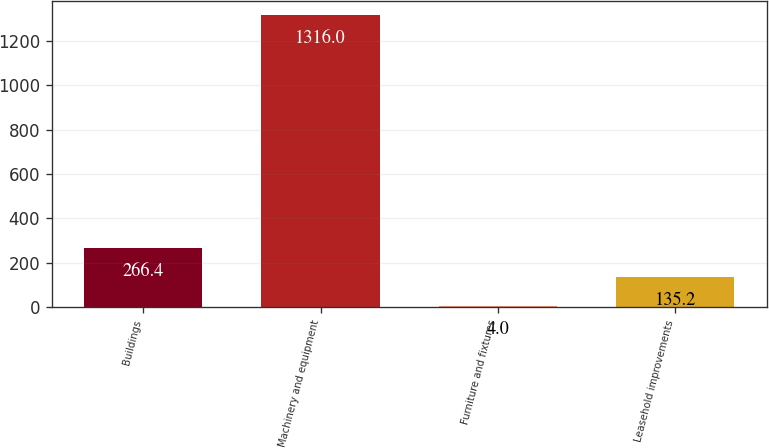Convert chart. <chart><loc_0><loc_0><loc_500><loc_500><bar_chart><fcel>Buildings<fcel>Machinery and equipment<fcel>Furniture and fixtures<fcel>Leasehold improvements<nl><fcel>266.4<fcel>1316<fcel>4<fcel>135.2<nl></chart> 